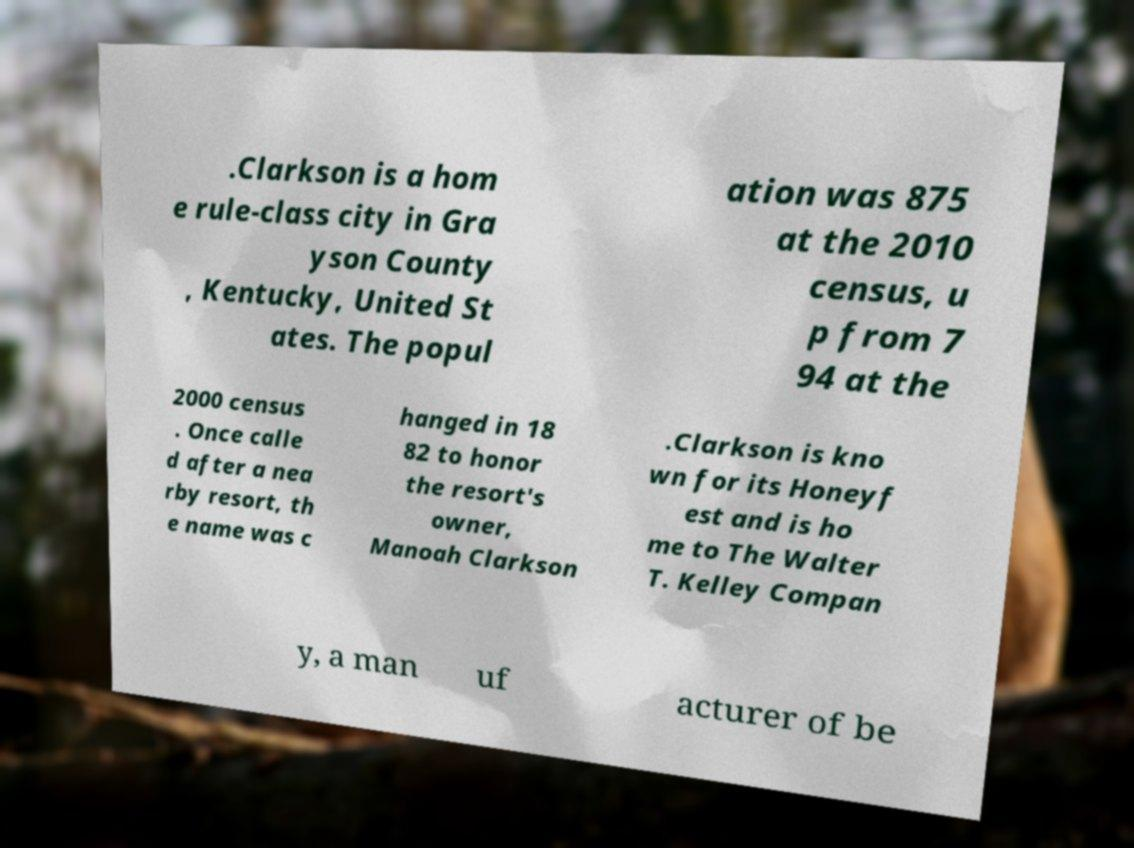Please identify and transcribe the text found in this image. .Clarkson is a hom e rule-class city in Gra yson County , Kentucky, United St ates. The popul ation was 875 at the 2010 census, u p from 7 94 at the 2000 census . Once calle d after a nea rby resort, th e name was c hanged in 18 82 to honor the resort's owner, Manoah Clarkson .Clarkson is kno wn for its Honeyf est and is ho me to The Walter T. Kelley Compan y, a man uf acturer of be 